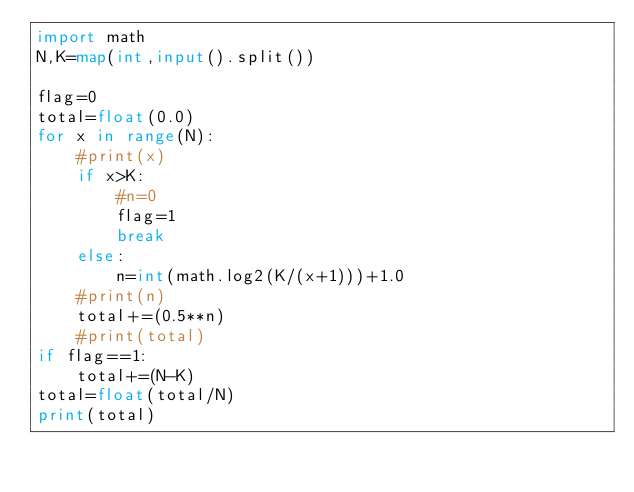<code> <loc_0><loc_0><loc_500><loc_500><_Python_>import math
N,K=map(int,input().split())

flag=0
total=float(0.0)
for x in range(N):
    #print(x)
    if x>K:
        #n=0
        flag=1
        break
    else:
        n=int(math.log2(K/(x+1)))+1.0
    #print(n)
    total+=(0.5**n)
    #print(total)
if flag==1:
    total+=(N-K)
total=float(total/N)
print(total)</code> 